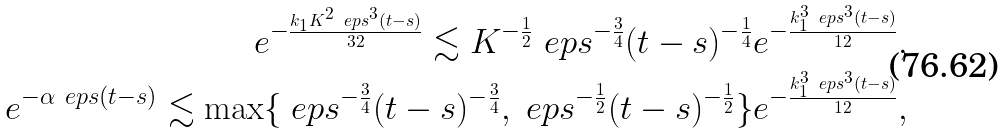<formula> <loc_0><loc_0><loc_500><loc_500>e ^ { - \frac { k _ { 1 } K ^ { 2 } \ e p s ^ { 3 } ( t - s ) } { 3 2 } } \lesssim K ^ { - \frac { 1 } { 2 } } \ e p s ^ { - \frac { 3 } { 4 } } ( t - s ) ^ { - \frac { 1 } { 4 } } e ^ { - \frac { k _ { 1 } ^ { 3 } \ e p s ^ { 3 } ( t - s ) } { 1 2 } } , \\ e ^ { - \alpha \ e p s ( t - s ) } \lesssim \max \{ \ e p s ^ { - \frac { 3 } { 4 } } ( t - s ) ^ { - \frac { 3 } { 4 } } , \ e p s ^ { - \frac { 1 } { 2 } } ( t - s ) ^ { - \frac { 1 } { 2 } } \} e ^ { - \frac { k _ { 1 } ^ { 3 } \ e p s ^ { 3 } ( t - s ) } { 1 2 } } ,</formula> 